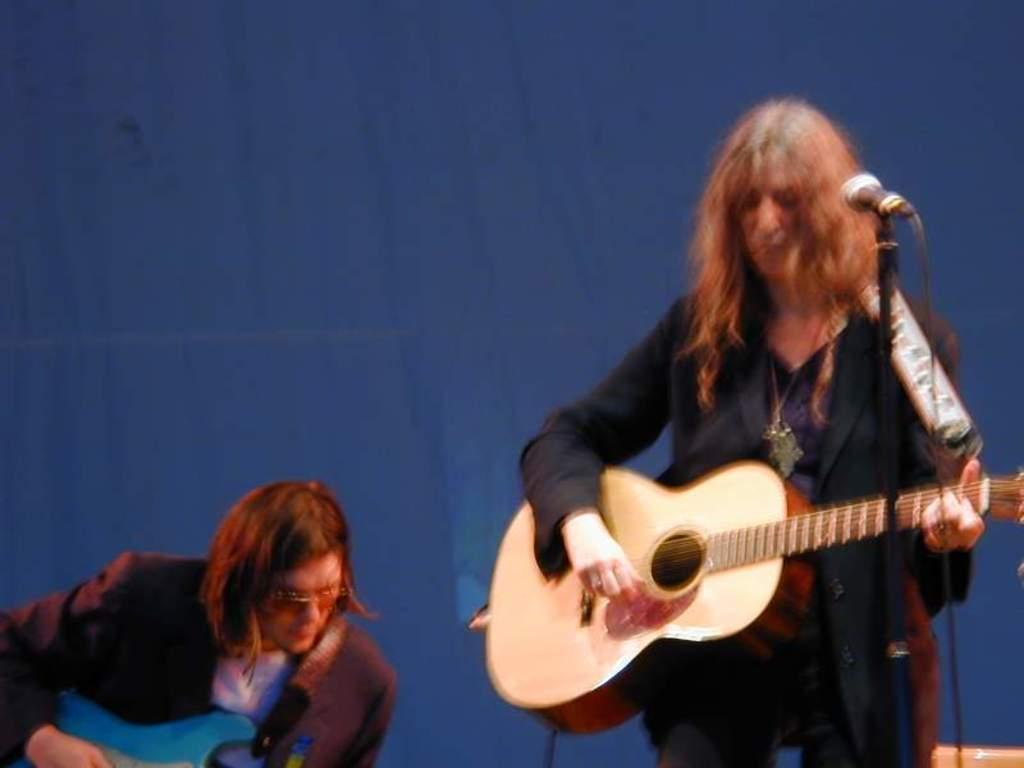Can you describe this image briefly? They are both playing musical instruments. They are wearing colorful dress. 